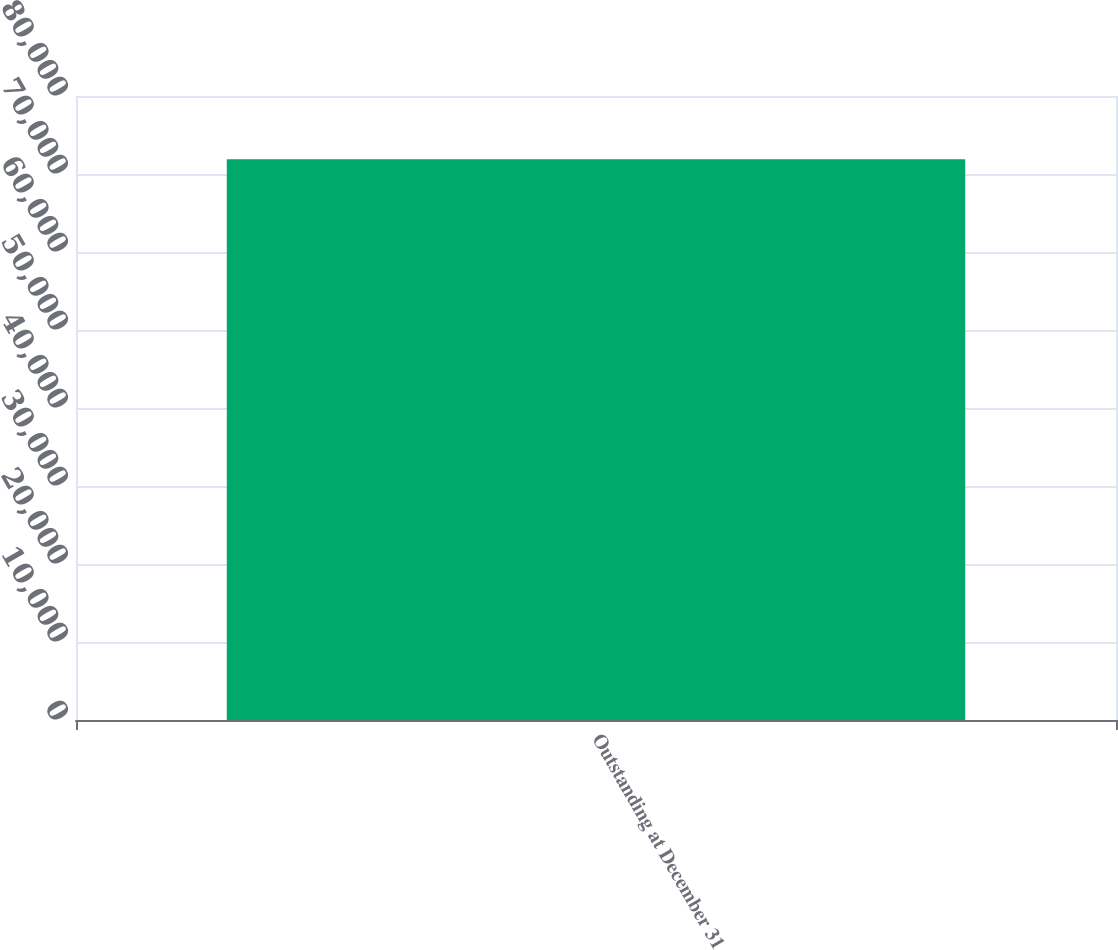Convert chart to OTSL. <chart><loc_0><loc_0><loc_500><loc_500><bar_chart><fcel>Outstanding at December 31<nl><fcel>71892<nl></chart> 